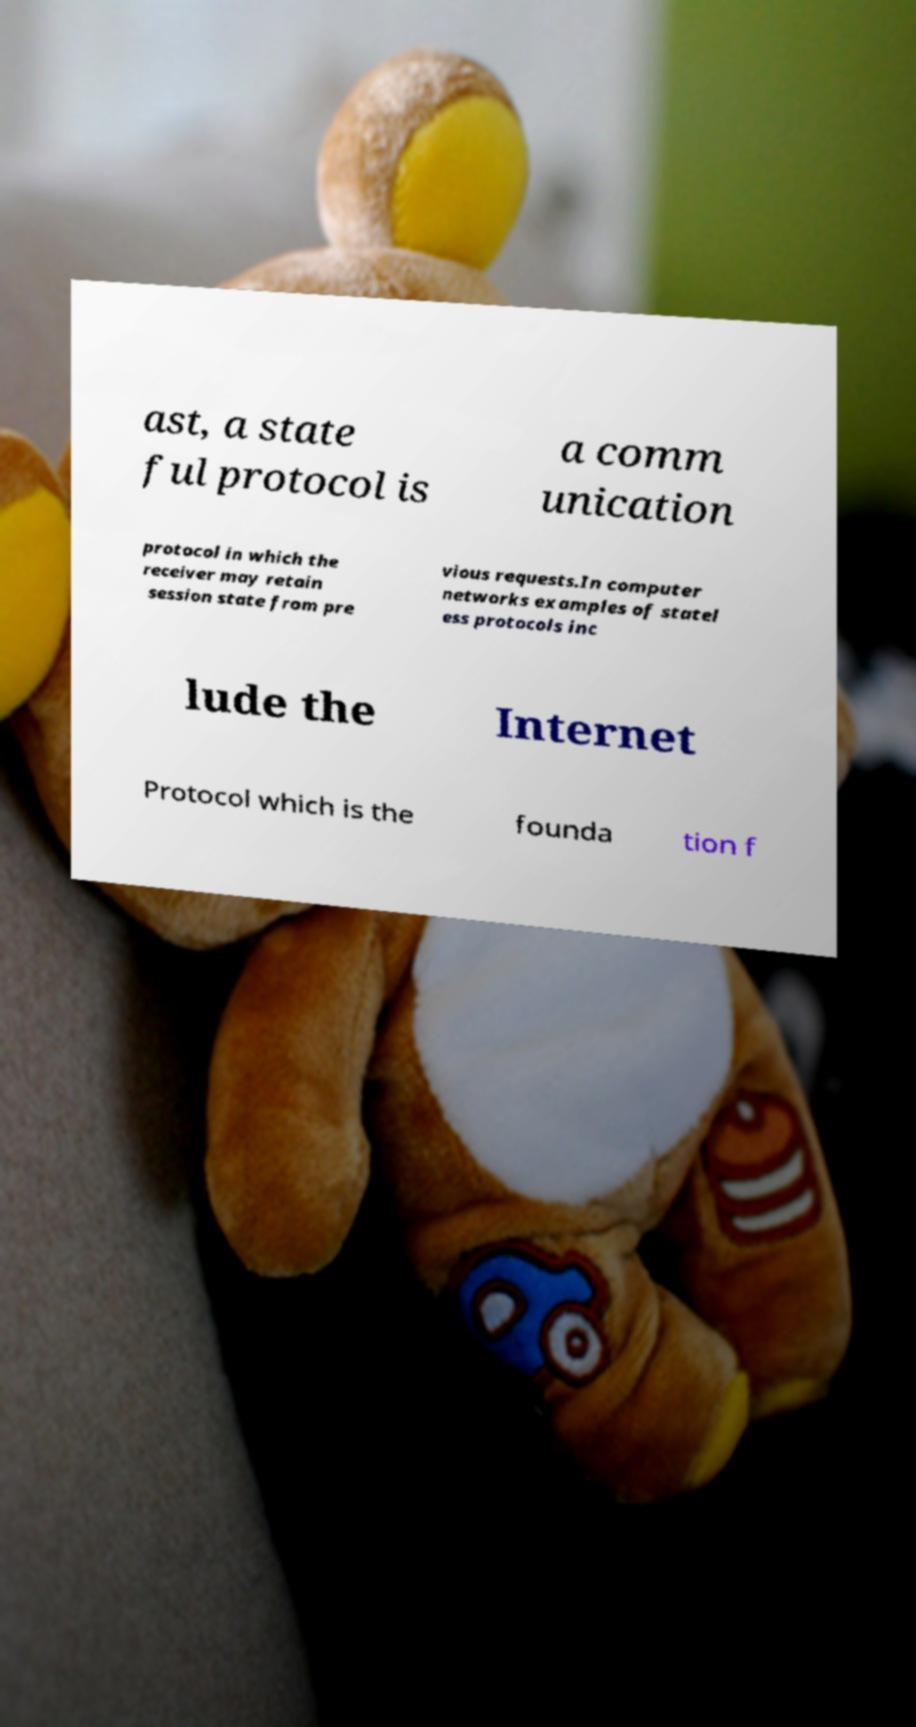There's text embedded in this image that I need extracted. Can you transcribe it verbatim? ast, a state ful protocol is a comm unication protocol in which the receiver may retain session state from pre vious requests.In computer networks examples of statel ess protocols inc lude the Internet Protocol which is the founda tion f 